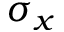<formula> <loc_0><loc_0><loc_500><loc_500>\sigma _ { x }</formula> 